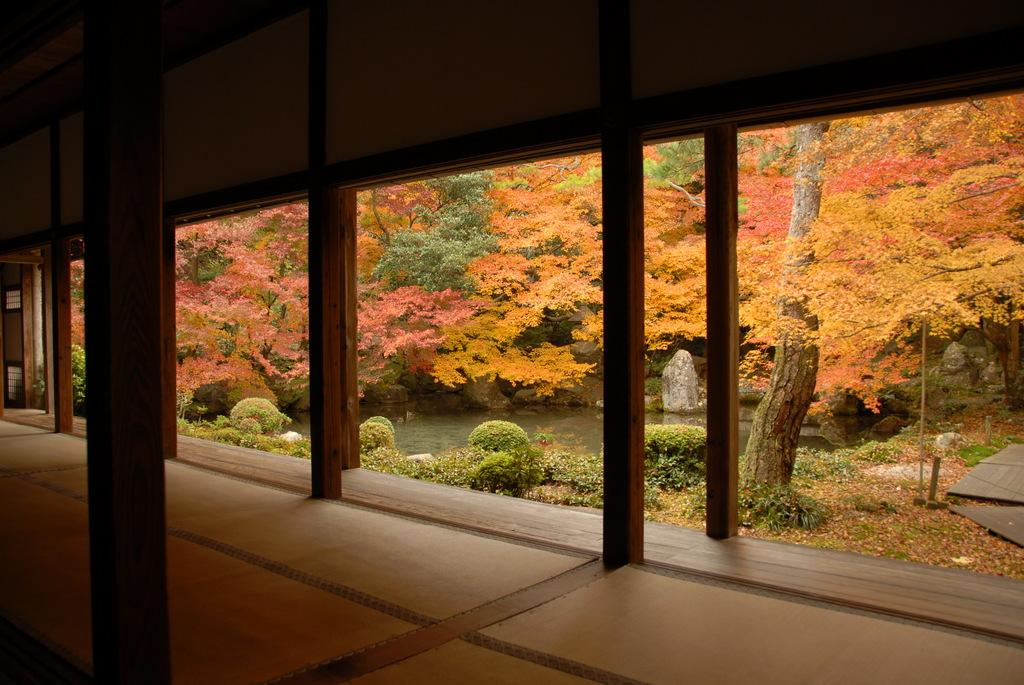What type of structure is visible in the image? There is a wooden compartment in the image. What supports the structure? There are wooden pillars in the image. What can be seen in the background of the image? There is a beautiful view of trees in the background. Is there any water feature in the area? Yes, there is a small pond in the area. What type of collar is being worn by the tree in the image? There are no collars present in the image, as trees do not wear collars. 